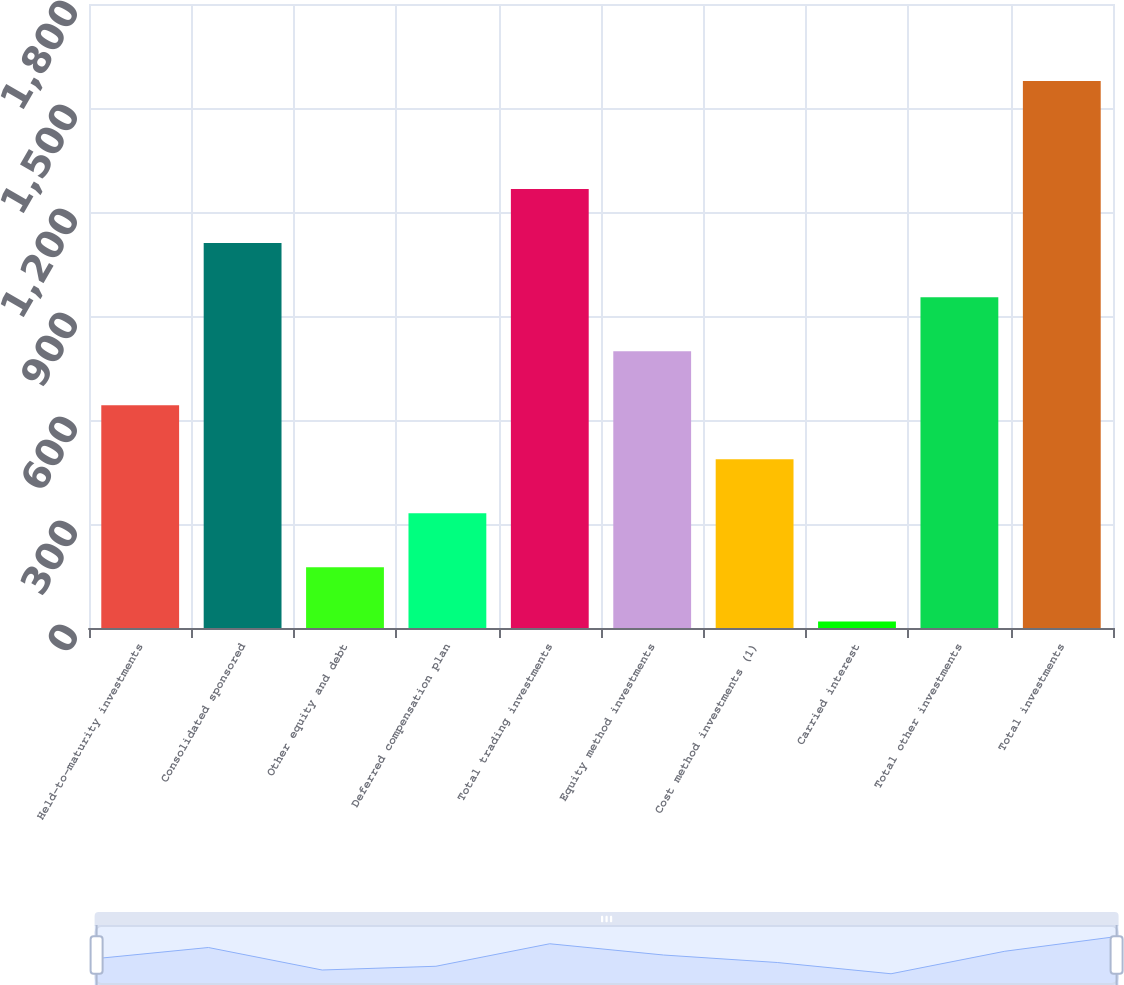Convert chart to OTSL. <chart><loc_0><loc_0><loc_500><loc_500><bar_chart><fcel>Held-to-maturity investments<fcel>Consolidated sponsored<fcel>Other equity and debt<fcel>Deferred compensation plan<fcel>Total trading investments<fcel>Equity method investments<fcel>Cost method investments (1)<fcel>Carried interest<fcel>Total other investments<fcel>Total investments<nl><fcel>642.6<fcel>1110.3<fcel>174.9<fcel>330.8<fcel>1266.2<fcel>798.5<fcel>486.7<fcel>19<fcel>954.4<fcel>1578<nl></chart> 